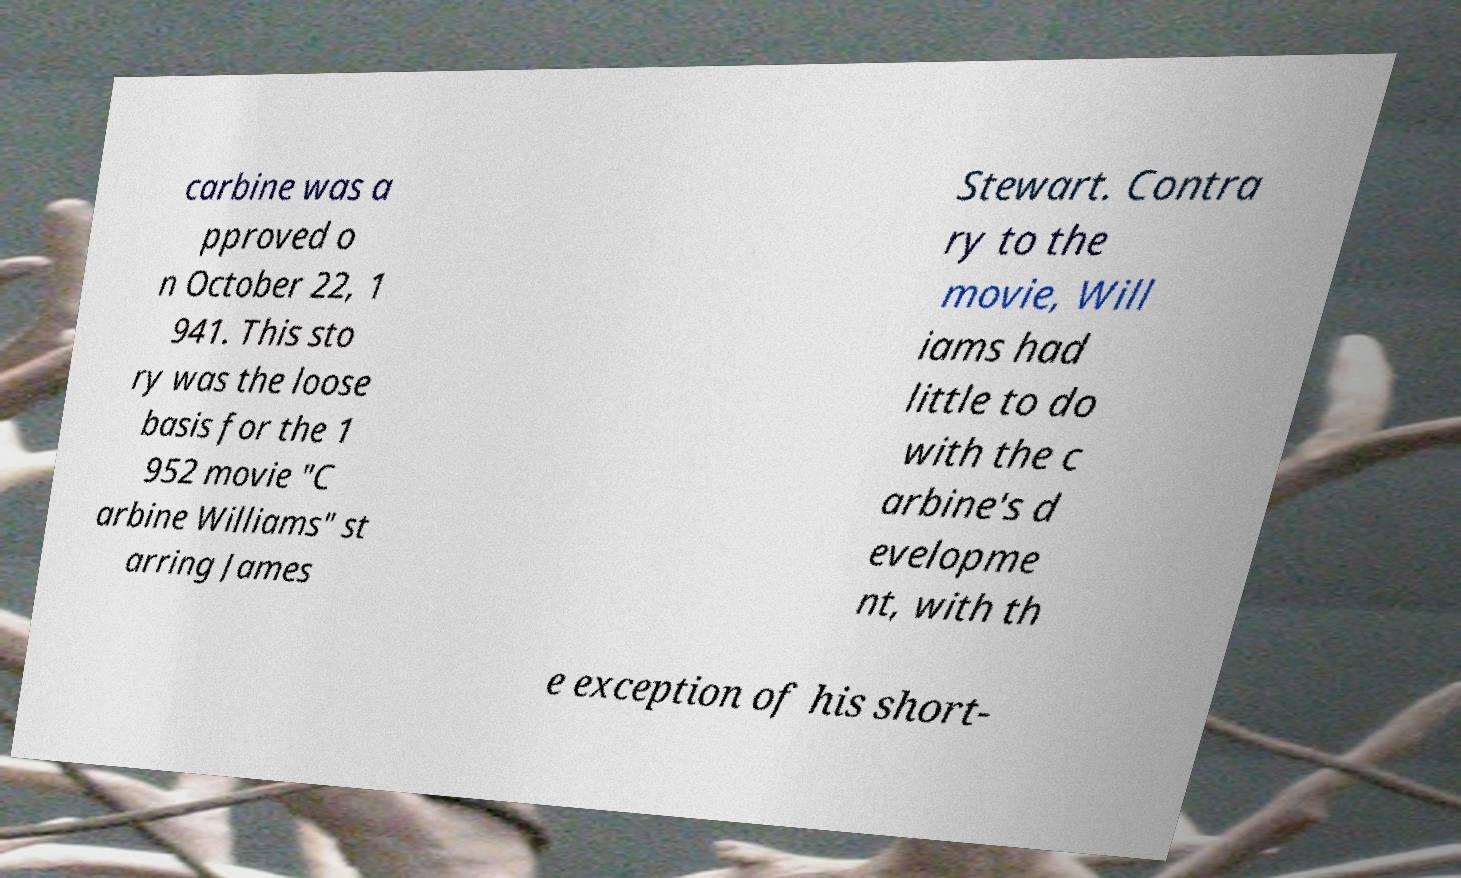What messages or text are displayed in this image? I need them in a readable, typed format. carbine was a pproved o n October 22, 1 941. This sto ry was the loose basis for the 1 952 movie "C arbine Williams" st arring James Stewart. Contra ry to the movie, Will iams had little to do with the c arbine's d evelopme nt, with th e exception of his short- 